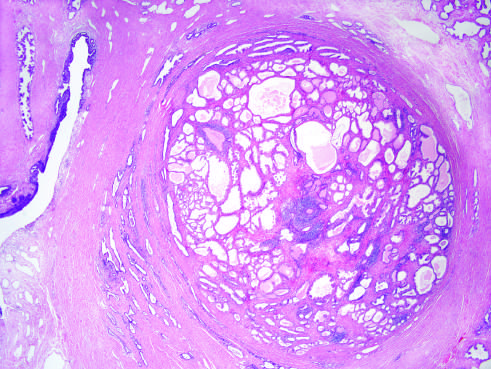what does the low-power photomicrograph demonstrate?
Answer the question using a single word or phrase. A well-demarcated nodule at the right of the field 